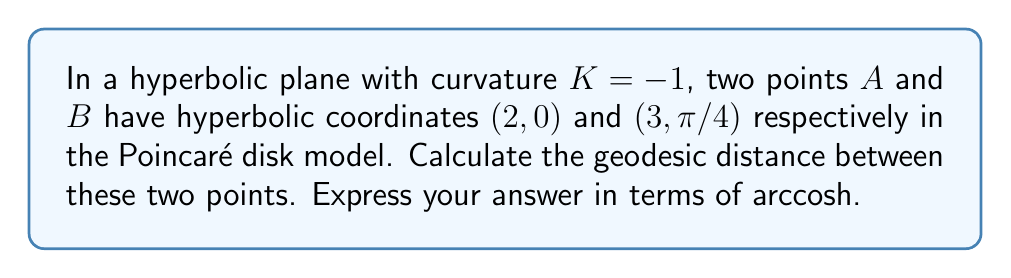Teach me how to tackle this problem. Let's approach this step-by-step:

1) In the Poincaré disk model of hyperbolic geometry, the distance $d$ between two points $(r_1, \theta_1)$ and $(r_2, \theta_2)$ is given by:

   $$d = \text{arccosh}\left(1 + \frac{2|z_1 - z_2|^2}{(1-|z_1|^2)(1-|z_2|^2)}\right)$$

   where $z_1 = r_1e^{i\theta_1}$ and $z_2 = r_2e^{i\theta_2}$ are the complex representations of the points.

2) For our points:
   $A: z_1 = 2e^{i\cdot 0} = 2$
   $B: z_2 = 3e^{i\pi/4} = 3(\frac{\sqrt{2}}{2} + i\frac{\sqrt{2}}{2})$

3) Calculate $|z_1 - z_2|^2$:
   $$\begin{align}
   |z_1 - z_2|^2 &= |2 - 3(\frac{\sqrt{2}}{2} + i\frac{\sqrt{2}}{2})|^2 \\
   &= (2 - 3\frac{\sqrt{2}}{2})^2 + (-3\frac{\sqrt{2}}{2})^2 \\
   &= 4 - 6\sqrt{2} + \frac{9}{2} + \frac{9}{2} \\
   &= 13 - 6\sqrt{2}
   \end{align}$$

4) Calculate $(1-|z_1|^2)(1-|z_2|^2)$:
   $$(1-2^2)(1-3^2) = (-3)(-8) = 24$$

5) Substitute into the distance formula:
   $$\begin{align}
   d &= \text{arccosh}\left(1 + \frac{2(13 - 6\sqrt{2})}{24}\right) \\
   &= \text{arccosh}\left(1 + \frac{13 - 6\sqrt{2}}{12}\right) \\
   &= \text{arccosh}\left(\frac{25 - 6\sqrt{2}}{12}\right)
   \end{align}$$
Answer: $\text{arccosh}\left(\frac{25 - 6\sqrt{2}}{12}\right)$ 